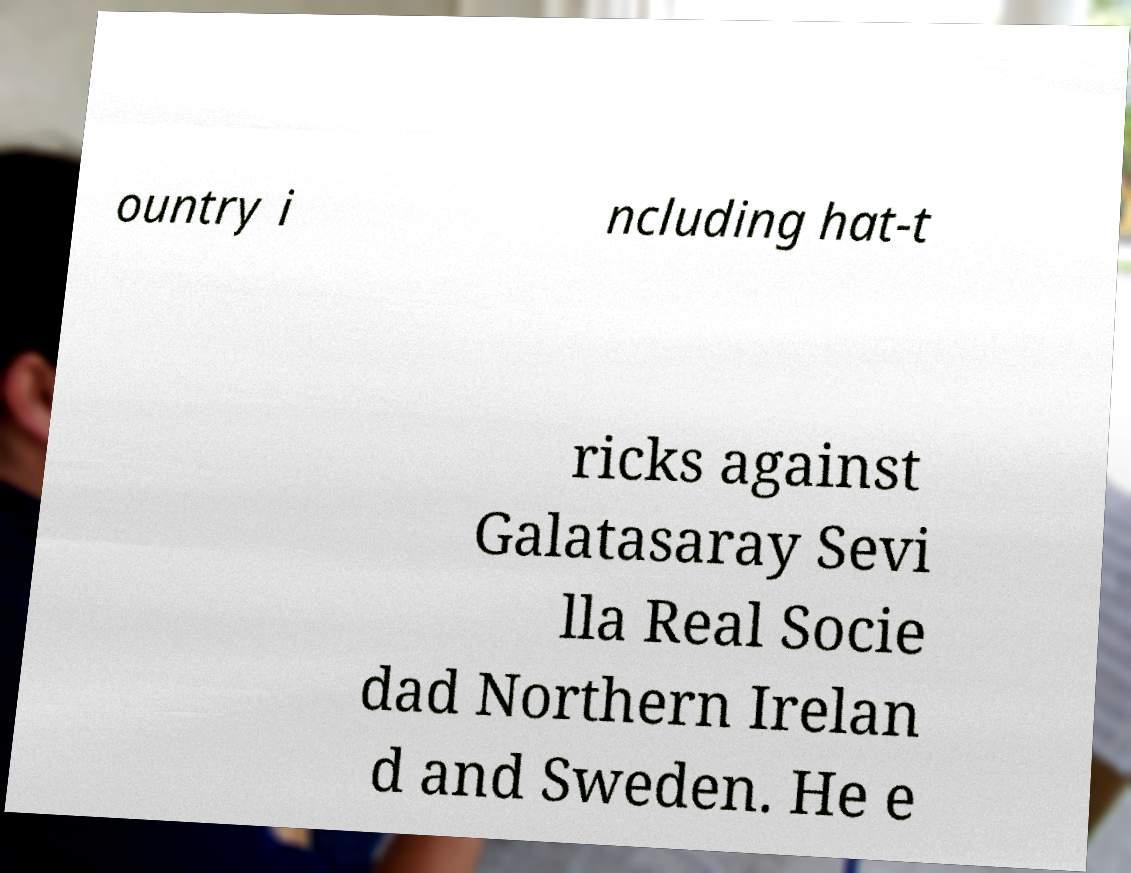Could you assist in decoding the text presented in this image and type it out clearly? ountry i ncluding hat-t ricks against Galatasaray Sevi lla Real Socie dad Northern Irelan d and Sweden. He e 